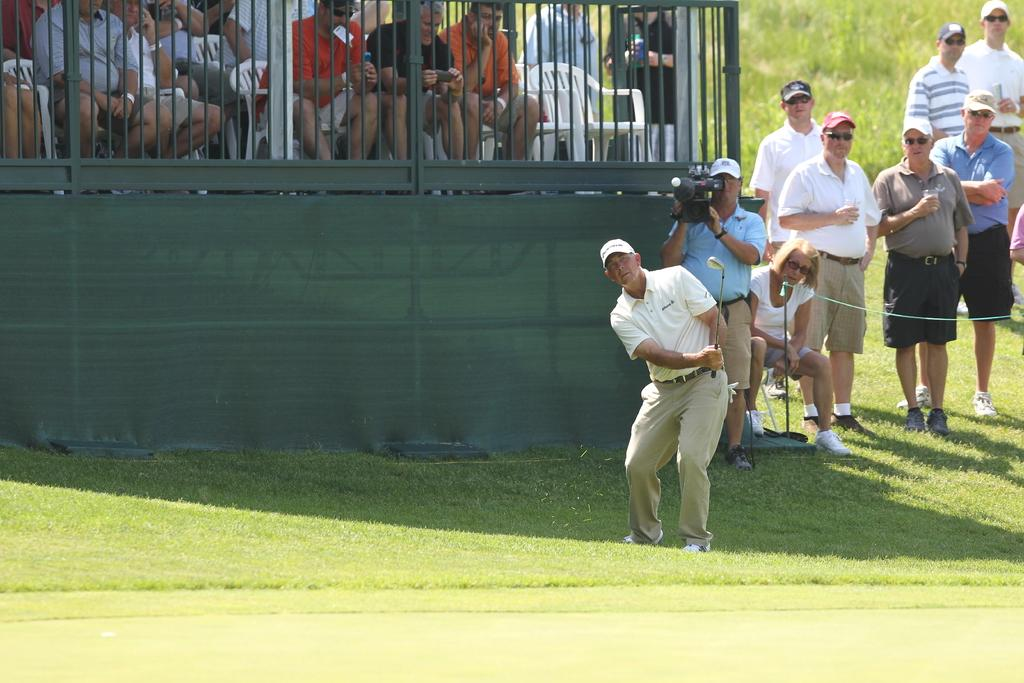What is the main subject of the image? The main subject of the image is a group of people. How are the people in the image positioned? Some people are sitting on chairs, while others are standing on the ground. What object can be seen in the image that is used for capturing images? There is a camera in the image. What type of natural environment is visible in the background of the image? There is grass visible in the background of the image. What type of hammer can be seen being used by the fairies in the image? There are no fairies or hammers present in the image; it features a group of people and a camera. 